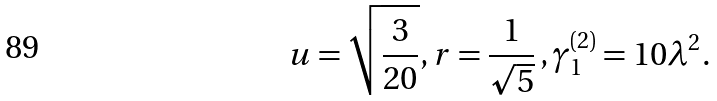Convert formula to latex. <formula><loc_0><loc_0><loc_500><loc_500>u = \sqrt { \frac { 3 } { 2 0 } } , r = \frac { 1 } { \sqrt { 5 } } \, , \gamma _ { 1 } ^ { ( 2 ) } = 1 0 \lambda ^ { 2 } .</formula> 